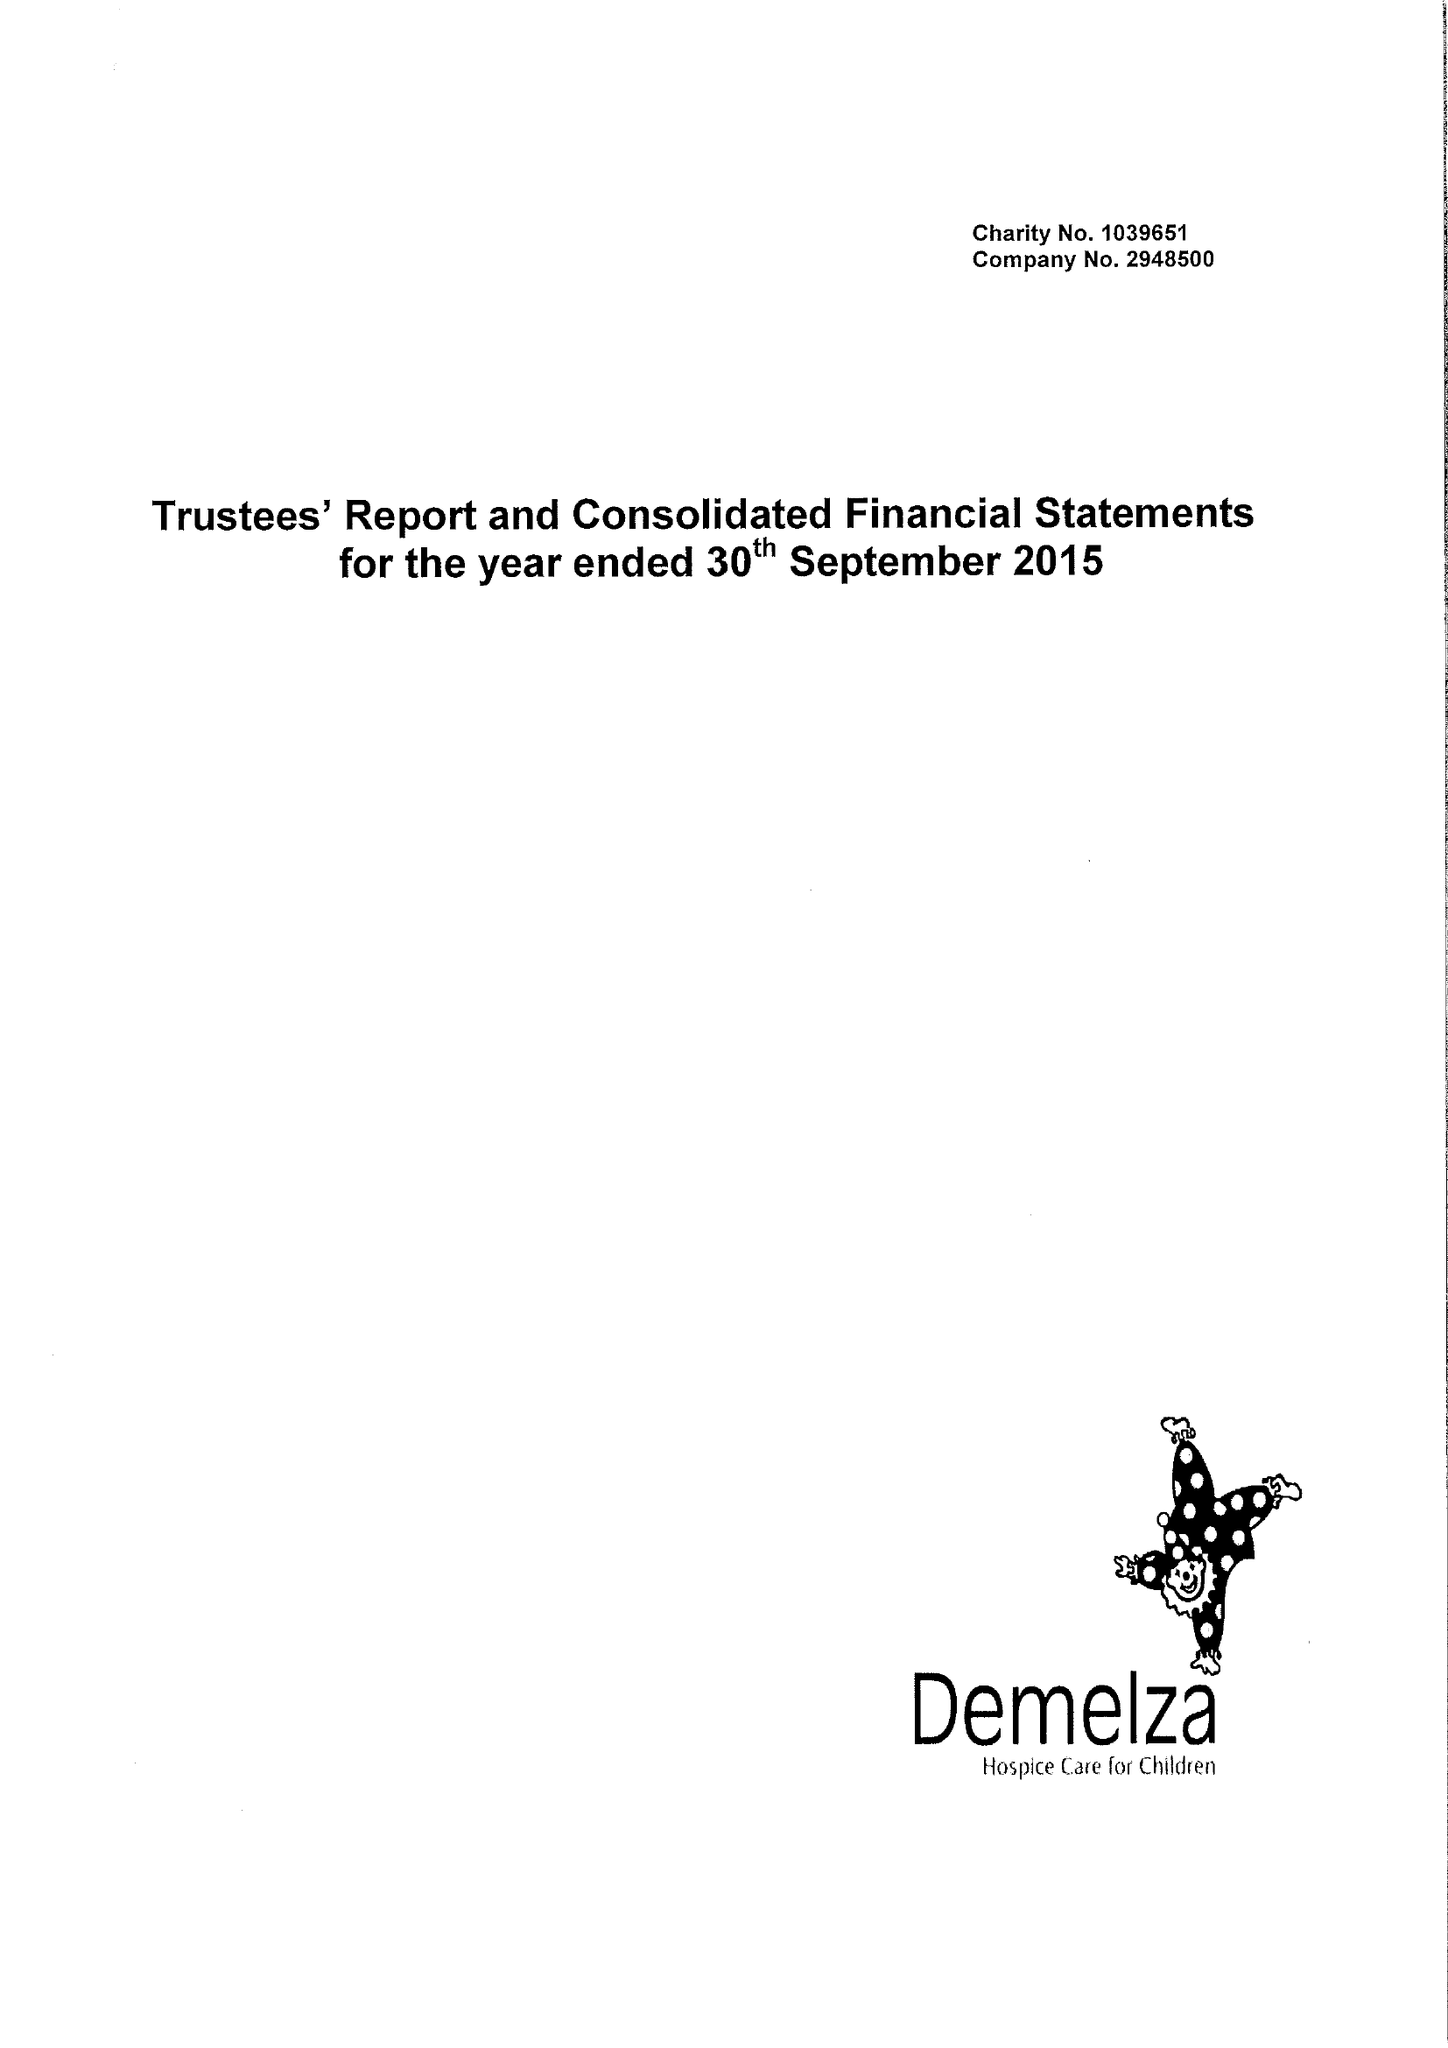What is the value for the report_date?
Answer the question using a single word or phrase. 2015-09-30 